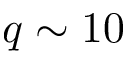<formula> <loc_0><loc_0><loc_500><loc_500>q \sim 1 0</formula> 